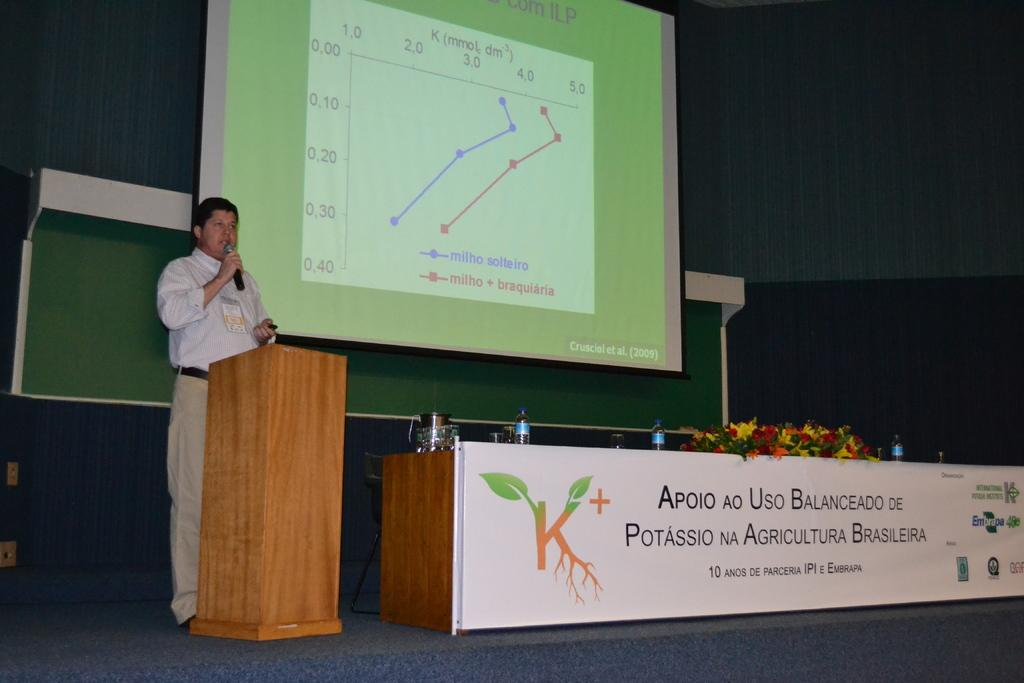What is the man in the image holding? The man is holding a mic. What is in front of the man? There is a podium in front of the man. What can be seen on the screen in the image? The facts do not specify what is on the screen, so we cannot answer this question definitively. What is on the table in the image? There is a table with a banner, bottles, and flowers in the image. How does the man express his anger while holding the mic in the image? The facts do not mention any anger or emotion expressed by the man, so we cannot answer this question definitively. 